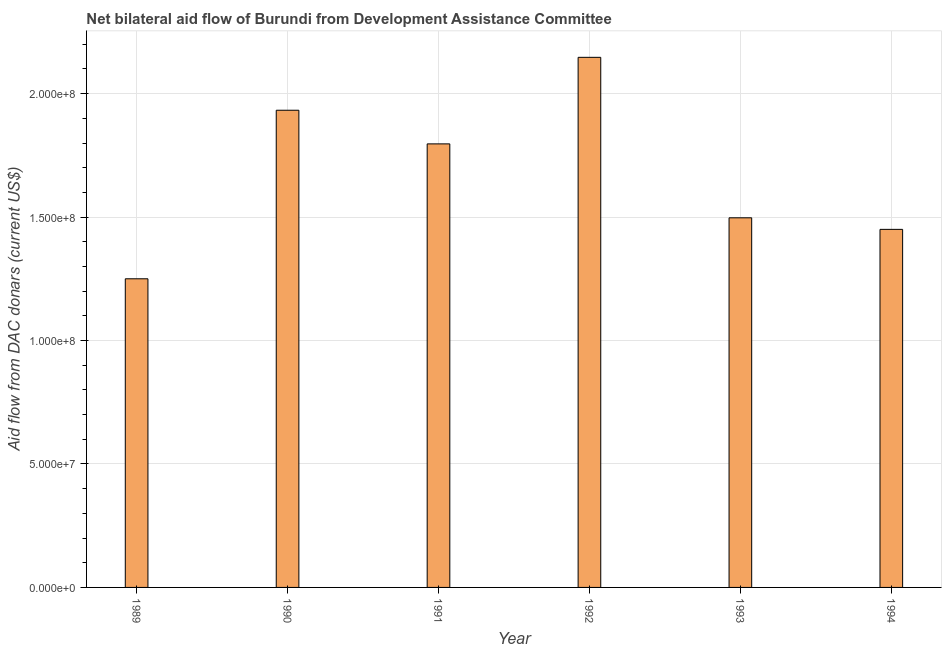Does the graph contain any zero values?
Offer a terse response. No. What is the title of the graph?
Keep it short and to the point. Net bilateral aid flow of Burundi from Development Assistance Committee. What is the label or title of the X-axis?
Ensure brevity in your answer.  Year. What is the label or title of the Y-axis?
Your answer should be compact. Aid flow from DAC donars (current US$). What is the net bilateral aid flows from dac donors in 1990?
Provide a succinct answer. 1.93e+08. Across all years, what is the maximum net bilateral aid flows from dac donors?
Keep it short and to the point. 2.15e+08. Across all years, what is the minimum net bilateral aid flows from dac donors?
Make the answer very short. 1.25e+08. In which year was the net bilateral aid flows from dac donors maximum?
Your answer should be very brief. 1992. What is the sum of the net bilateral aid flows from dac donors?
Offer a very short reply. 1.01e+09. What is the difference between the net bilateral aid flows from dac donors in 1990 and 1993?
Your answer should be compact. 4.36e+07. What is the average net bilateral aid flows from dac donors per year?
Make the answer very short. 1.68e+08. What is the median net bilateral aid flows from dac donors?
Provide a succinct answer. 1.65e+08. What is the ratio of the net bilateral aid flows from dac donors in 1989 to that in 1992?
Offer a terse response. 0.58. Is the net bilateral aid flows from dac donors in 1990 less than that in 1993?
Your answer should be compact. No. Is the difference between the net bilateral aid flows from dac donors in 1991 and 1993 greater than the difference between any two years?
Your answer should be compact. No. What is the difference between the highest and the second highest net bilateral aid flows from dac donors?
Keep it short and to the point. 2.14e+07. Is the sum of the net bilateral aid flows from dac donors in 1991 and 1994 greater than the maximum net bilateral aid flows from dac donors across all years?
Offer a terse response. Yes. What is the difference between the highest and the lowest net bilateral aid flows from dac donors?
Keep it short and to the point. 8.97e+07. Are the values on the major ticks of Y-axis written in scientific E-notation?
Your response must be concise. Yes. What is the Aid flow from DAC donars (current US$) in 1989?
Ensure brevity in your answer.  1.25e+08. What is the Aid flow from DAC donars (current US$) of 1990?
Offer a very short reply. 1.93e+08. What is the Aid flow from DAC donars (current US$) in 1991?
Your answer should be very brief. 1.80e+08. What is the Aid flow from DAC donars (current US$) in 1992?
Your answer should be compact. 2.15e+08. What is the Aid flow from DAC donars (current US$) of 1993?
Provide a succinct answer. 1.50e+08. What is the Aid flow from DAC donars (current US$) of 1994?
Your answer should be compact. 1.45e+08. What is the difference between the Aid flow from DAC donars (current US$) in 1989 and 1990?
Provide a short and direct response. -6.83e+07. What is the difference between the Aid flow from DAC donars (current US$) in 1989 and 1991?
Keep it short and to the point. -5.46e+07. What is the difference between the Aid flow from DAC donars (current US$) in 1989 and 1992?
Ensure brevity in your answer.  -8.97e+07. What is the difference between the Aid flow from DAC donars (current US$) in 1989 and 1993?
Offer a terse response. -2.47e+07. What is the difference between the Aid flow from DAC donars (current US$) in 1989 and 1994?
Your answer should be very brief. -2.00e+07. What is the difference between the Aid flow from DAC donars (current US$) in 1990 and 1991?
Offer a terse response. 1.36e+07. What is the difference between the Aid flow from DAC donars (current US$) in 1990 and 1992?
Provide a succinct answer. -2.14e+07. What is the difference between the Aid flow from DAC donars (current US$) in 1990 and 1993?
Your answer should be compact. 4.36e+07. What is the difference between the Aid flow from DAC donars (current US$) in 1990 and 1994?
Offer a terse response. 4.82e+07. What is the difference between the Aid flow from DAC donars (current US$) in 1991 and 1992?
Make the answer very short. -3.51e+07. What is the difference between the Aid flow from DAC donars (current US$) in 1991 and 1993?
Your response must be concise. 2.99e+07. What is the difference between the Aid flow from DAC donars (current US$) in 1991 and 1994?
Offer a terse response. 3.46e+07. What is the difference between the Aid flow from DAC donars (current US$) in 1992 and 1993?
Offer a very short reply. 6.50e+07. What is the difference between the Aid flow from DAC donars (current US$) in 1992 and 1994?
Your answer should be compact. 6.97e+07. What is the difference between the Aid flow from DAC donars (current US$) in 1993 and 1994?
Ensure brevity in your answer.  4.68e+06. What is the ratio of the Aid flow from DAC donars (current US$) in 1989 to that in 1990?
Keep it short and to the point. 0.65. What is the ratio of the Aid flow from DAC donars (current US$) in 1989 to that in 1991?
Ensure brevity in your answer.  0.7. What is the ratio of the Aid flow from DAC donars (current US$) in 1989 to that in 1992?
Keep it short and to the point. 0.58. What is the ratio of the Aid flow from DAC donars (current US$) in 1989 to that in 1993?
Provide a succinct answer. 0.83. What is the ratio of the Aid flow from DAC donars (current US$) in 1989 to that in 1994?
Give a very brief answer. 0.86. What is the ratio of the Aid flow from DAC donars (current US$) in 1990 to that in 1991?
Provide a succinct answer. 1.08. What is the ratio of the Aid flow from DAC donars (current US$) in 1990 to that in 1992?
Make the answer very short. 0.9. What is the ratio of the Aid flow from DAC donars (current US$) in 1990 to that in 1993?
Provide a succinct answer. 1.29. What is the ratio of the Aid flow from DAC donars (current US$) in 1990 to that in 1994?
Provide a short and direct response. 1.33. What is the ratio of the Aid flow from DAC donars (current US$) in 1991 to that in 1992?
Offer a very short reply. 0.84. What is the ratio of the Aid flow from DAC donars (current US$) in 1991 to that in 1993?
Offer a terse response. 1.2. What is the ratio of the Aid flow from DAC donars (current US$) in 1991 to that in 1994?
Give a very brief answer. 1.24. What is the ratio of the Aid flow from DAC donars (current US$) in 1992 to that in 1993?
Provide a short and direct response. 1.43. What is the ratio of the Aid flow from DAC donars (current US$) in 1992 to that in 1994?
Provide a short and direct response. 1.48. What is the ratio of the Aid flow from DAC donars (current US$) in 1993 to that in 1994?
Offer a terse response. 1.03. 